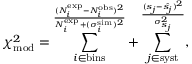<formula> <loc_0><loc_0><loc_500><loc_500>\chi _ { m o d } ^ { 2 } = \sum _ { i \in b i n s } ^ { } ( N _ { i } ^ { e x p } - N _ { i } ^ { o b s } ) ^ { 2 } } { N _ { i } ^ { e x p } + ( \sigma _ { i } ^ { s i m } ) ^ { 2 } } + \sum _ { j \in s y s t } ^ { } ( s _ { j } - \hat { s _ { j } } ) ^ { 2 } } { \sigma _ { s _ { j } } ^ { 2 } } ,</formula> 